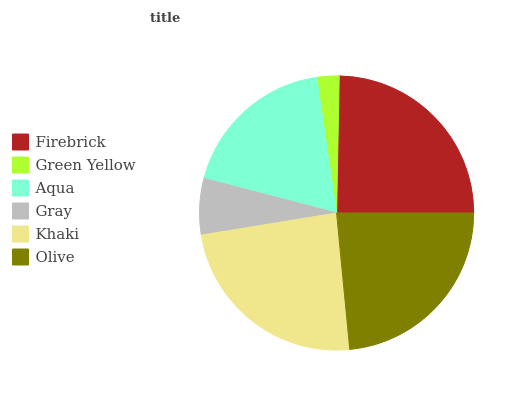Is Green Yellow the minimum?
Answer yes or no. Yes. Is Firebrick the maximum?
Answer yes or no. Yes. Is Aqua the minimum?
Answer yes or no. No. Is Aqua the maximum?
Answer yes or no. No. Is Aqua greater than Green Yellow?
Answer yes or no. Yes. Is Green Yellow less than Aqua?
Answer yes or no. Yes. Is Green Yellow greater than Aqua?
Answer yes or no. No. Is Aqua less than Green Yellow?
Answer yes or no. No. Is Olive the high median?
Answer yes or no. Yes. Is Aqua the low median?
Answer yes or no. Yes. Is Gray the high median?
Answer yes or no. No. Is Olive the low median?
Answer yes or no. No. 